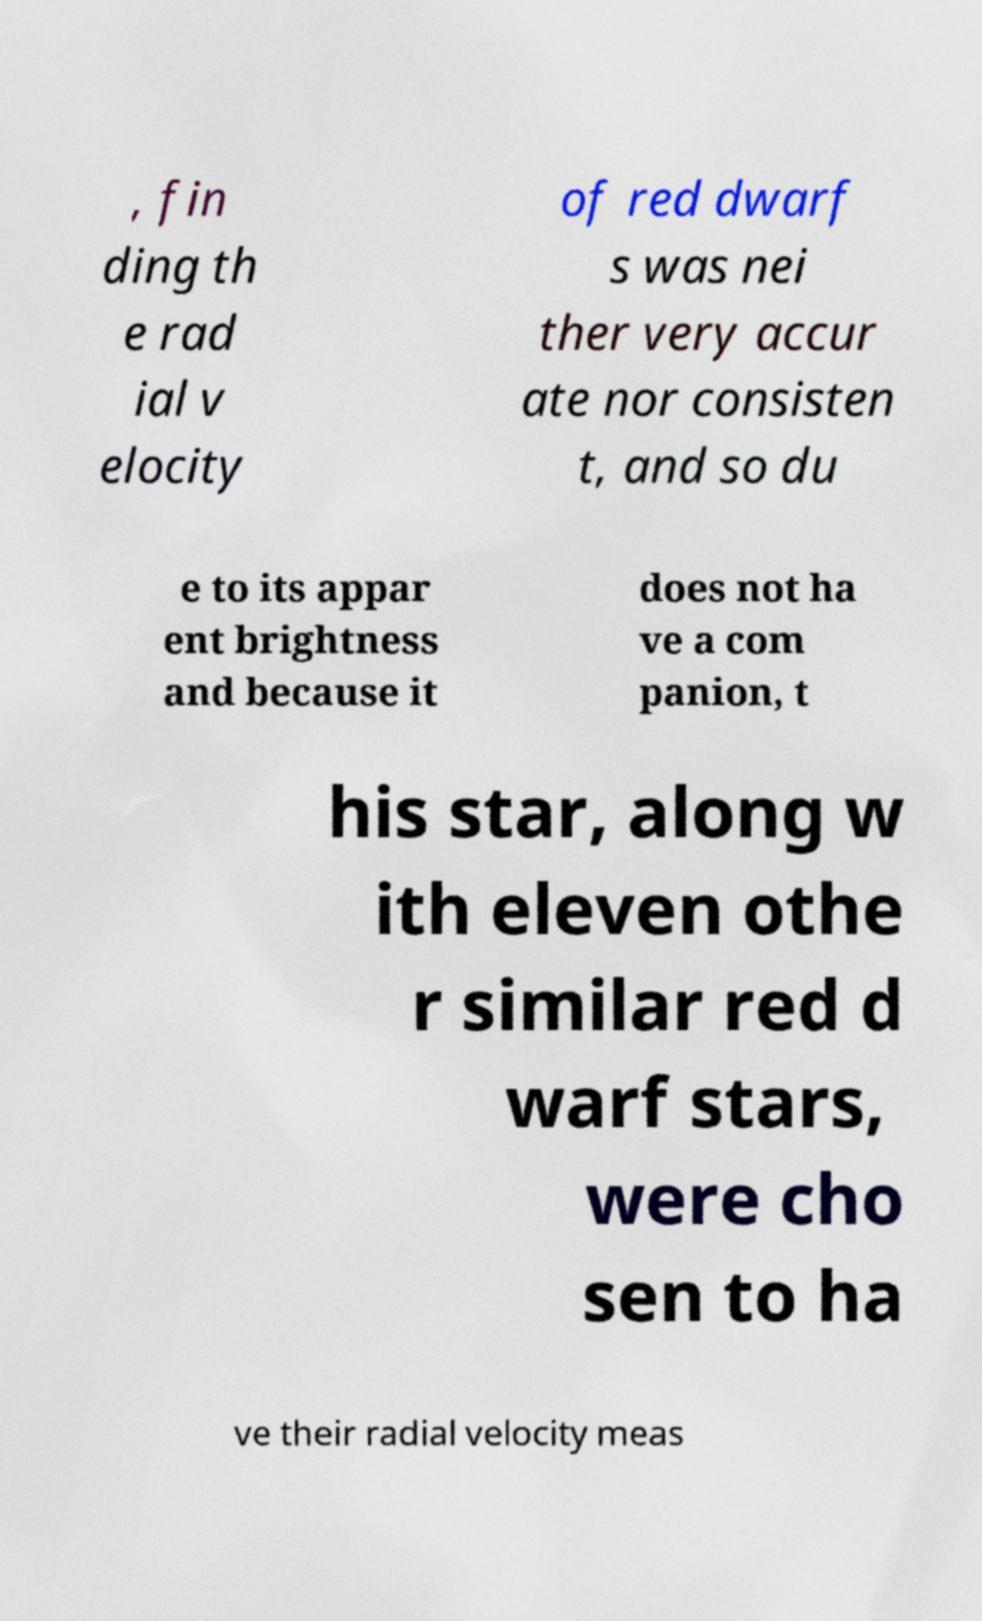Please identify and transcribe the text found in this image. , fin ding th e rad ial v elocity of red dwarf s was nei ther very accur ate nor consisten t, and so du e to its appar ent brightness and because it does not ha ve a com panion, t his star, along w ith eleven othe r similar red d warf stars, were cho sen to ha ve their radial velocity meas 